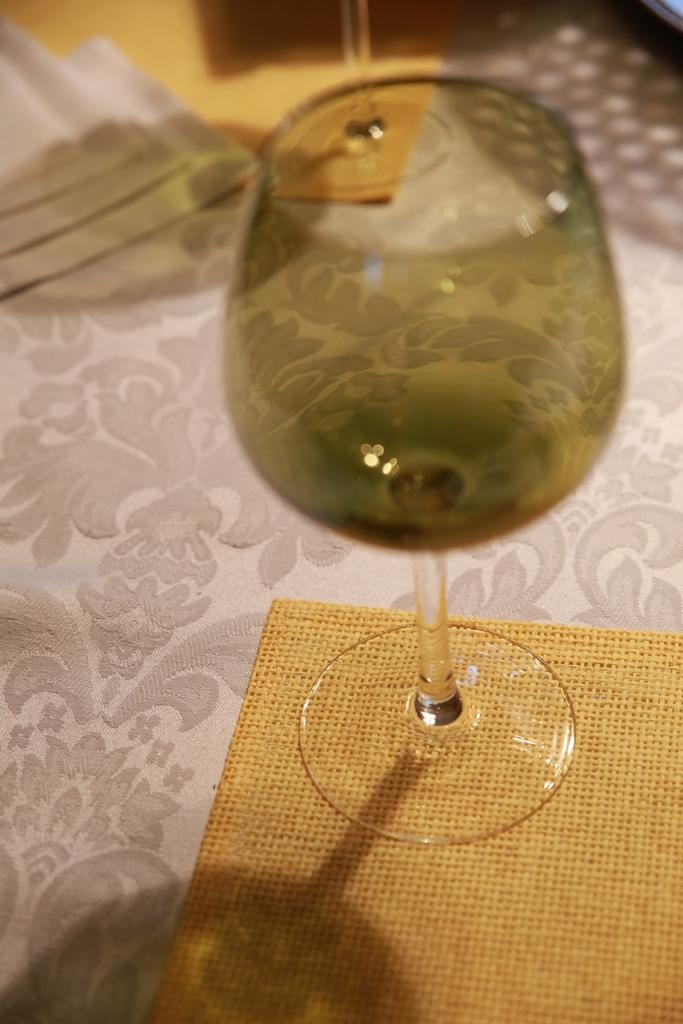What object can be seen in the image that is typically used for holding liquids? There is a glass in the image that is typically used for holding liquids. What type of items are present on the platform in the image? There are papers in the image, in addition to the glass. Where are the glass and papers located in the image? The glass and papers are placed on a platform in the image. What shape is the lip of the glass in the image? The image does not show the lip of the glass, so it cannot be determined from the image. 